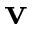<formula> <loc_0><loc_0><loc_500><loc_500>v</formula> 